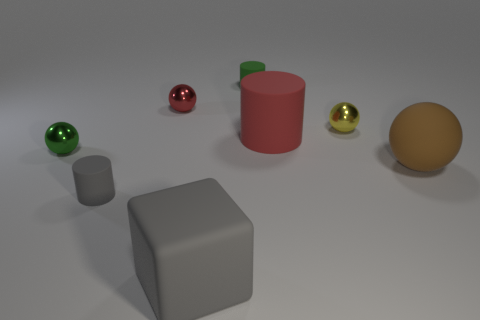Add 1 cylinders. How many objects exist? 9 Subtract all cylinders. How many objects are left? 5 Subtract 1 yellow spheres. How many objects are left? 7 Subtract all yellow metal balls. Subtract all big rubber cylinders. How many objects are left? 6 Add 7 small red metal spheres. How many small red metal spheres are left? 8 Add 4 big brown blocks. How many big brown blocks exist? 4 